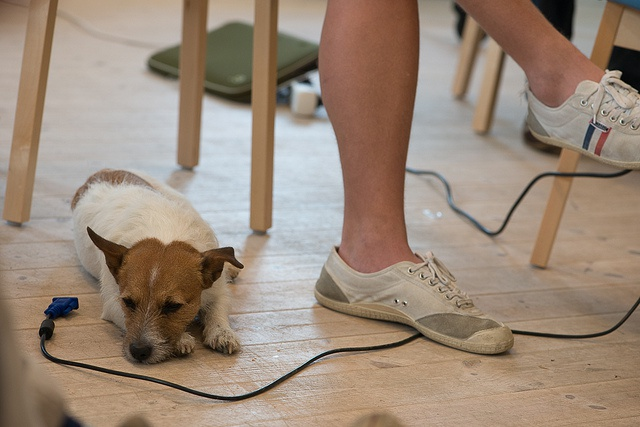Describe the objects in this image and their specific colors. I can see people in maroon, brown, darkgray, and gray tones, dog in maroon, darkgray, and tan tones, chair in maroon, gray, tan, brown, and darkgray tones, laptop in maroon, gray, darkgreen, black, and darkgray tones, and chair in maroon, gray, and brown tones in this image. 